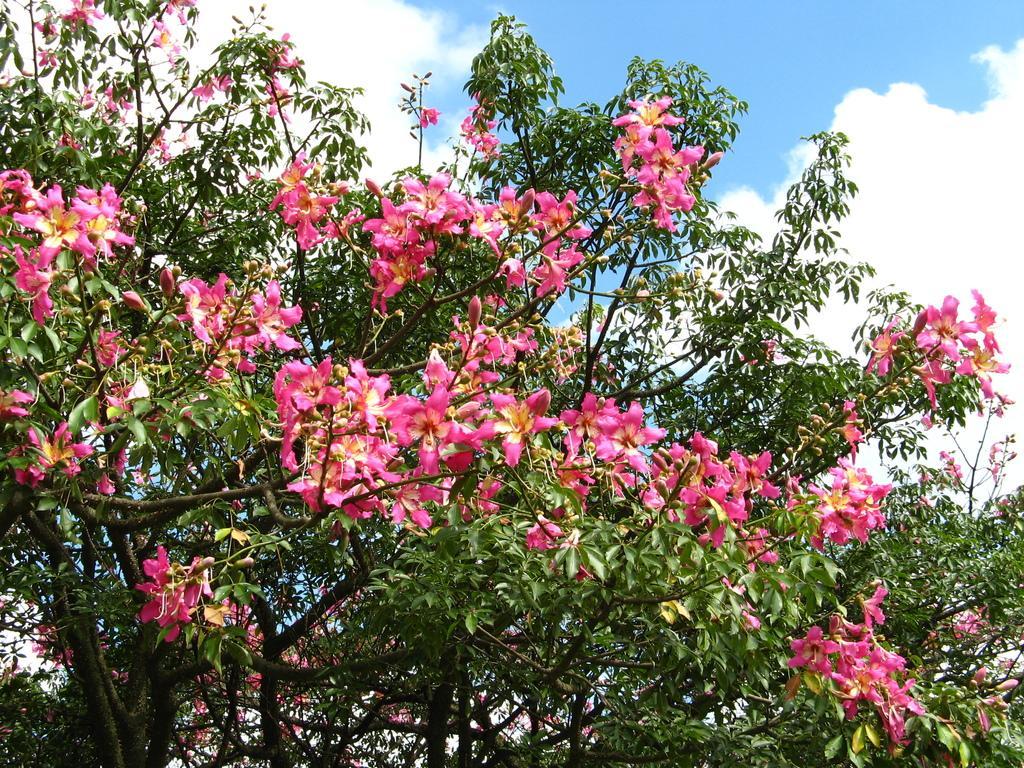How would you summarize this image in a sentence or two? In this image we can see many branches of a tree and there are many flowers and the background is the sky. 